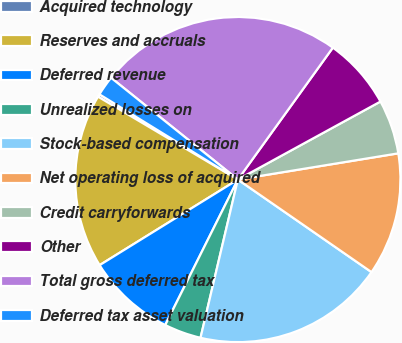Convert chart. <chart><loc_0><loc_0><loc_500><loc_500><pie_chart><fcel>Acquired technology<fcel>Reserves and accruals<fcel>Deferred revenue<fcel>Unrealized losses on<fcel>Stock-based compensation<fcel>Net operating loss of acquired<fcel>Credit carryforwards<fcel>Other<fcel>Total gross deferred tax<fcel>Deferred tax asset valuation<nl><fcel>0.27%<fcel>17.34%<fcel>8.81%<fcel>3.68%<fcel>19.05%<fcel>12.22%<fcel>5.39%<fcel>7.1%<fcel>24.17%<fcel>1.98%<nl></chart> 